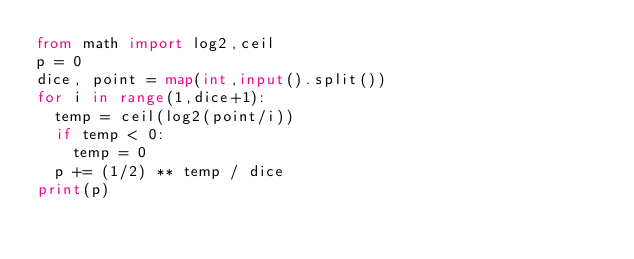Convert code to text. <code><loc_0><loc_0><loc_500><loc_500><_Python_>from math import log2,ceil
p = 0
dice, point = map(int,input().split())
for i in range(1,dice+1):
  temp = ceil(log2(point/i))
  if temp < 0:
    temp = 0
  p += (1/2) ** temp / dice
print(p)
</code> 